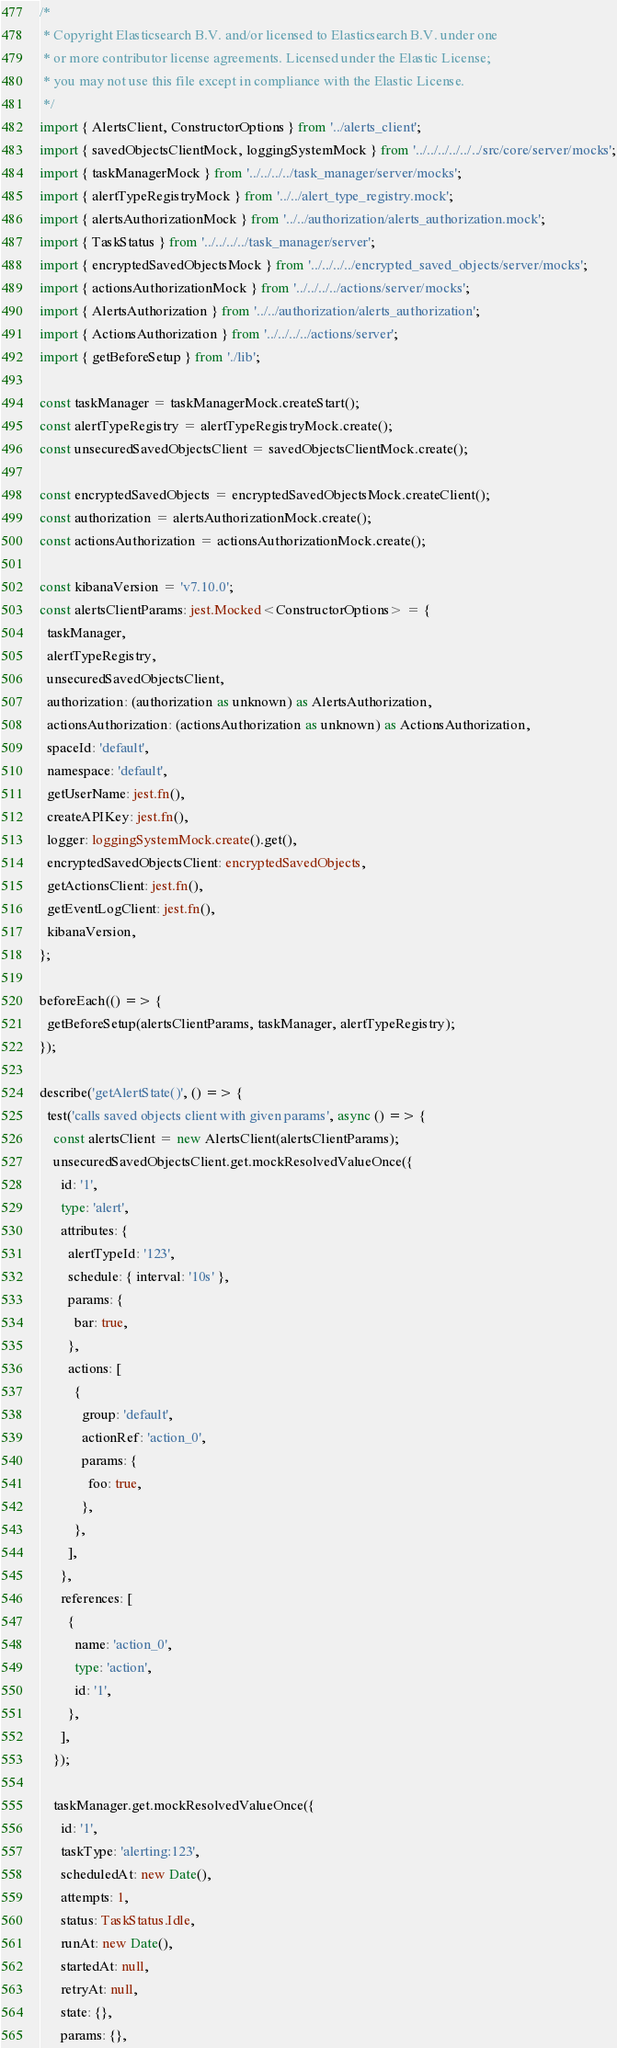Convert code to text. <code><loc_0><loc_0><loc_500><loc_500><_TypeScript_>/*
 * Copyright Elasticsearch B.V. and/or licensed to Elasticsearch B.V. under one
 * or more contributor license agreements. Licensed under the Elastic License;
 * you may not use this file except in compliance with the Elastic License.
 */
import { AlertsClient, ConstructorOptions } from '../alerts_client';
import { savedObjectsClientMock, loggingSystemMock } from '../../../../../../src/core/server/mocks';
import { taskManagerMock } from '../../../../task_manager/server/mocks';
import { alertTypeRegistryMock } from '../../alert_type_registry.mock';
import { alertsAuthorizationMock } from '../../authorization/alerts_authorization.mock';
import { TaskStatus } from '../../../../task_manager/server';
import { encryptedSavedObjectsMock } from '../../../../encrypted_saved_objects/server/mocks';
import { actionsAuthorizationMock } from '../../../../actions/server/mocks';
import { AlertsAuthorization } from '../../authorization/alerts_authorization';
import { ActionsAuthorization } from '../../../../actions/server';
import { getBeforeSetup } from './lib';

const taskManager = taskManagerMock.createStart();
const alertTypeRegistry = alertTypeRegistryMock.create();
const unsecuredSavedObjectsClient = savedObjectsClientMock.create();

const encryptedSavedObjects = encryptedSavedObjectsMock.createClient();
const authorization = alertsAuthorizationMock.create();
const actionsAuthorization = actionsAuthorizationMock.create();

const kibanaVersion = 'v7.10.0';
const alertsClientParams: jest.Mocked<ConstructorOptions> = {
  taskManager,
  alertTypeRegistry,
  unsecuredSavedObjectsClient,
  authorization: (authorization as unknown) as AlertsAuthorization,
  actionsAuthorization: (actionsAuthorization as unknown) as ActionsAuthorization,
  spaceId: 'default',
  namespace: 'default',
  getUserName: jest.fn(),
  createAPIKey: jest.fn(),
  logger: loggingSystemMock.create().get(),
  encryptedSavedObjectsClient: encryptedSavedObjects,
  getActionsClient: jest.fn(),
  getEventLogClient: jest.fn(),
  kibanaVersion,
};

beforeEach(() => {
  getBeforeSetup(alertsClientParams, taskManager, alertTypeRegistry);
});

describe('getAlertState()', () => {
  test('calls saved objects client with given params', async () => {
    const alertsClient = new AlertsClient(alertsClientParams);
    unsecuredSavedObjectsClient.get.mockResolvedValueOnce({
      id: '1',
      type: 'alert',
      attributes: {
        alertTypeId: '123',
        schedule: { interval: '10s' },
        params: {
          bar: true,
        },
        actions: [
          {
            group: 'default',
            actionRef: 'action_0',
            params: {
              foo: true,
            },
          },
        ],
      },
      references: [
        {
          name: 'action_0',
          type: 'action',
          id: '1',
        },
      ],
    });

    taskManager.get.mockResolvedValueOnce({
      id: '1',
      taskType: 'alerting:123',
      scheduledAt: new Date(),
      attempts: 1,
      status: TaskStatus.Idle,
      runAt: new Date(),
      startedAt: null,
      retryAt: null,
      state: {},
      params: {},</code> 